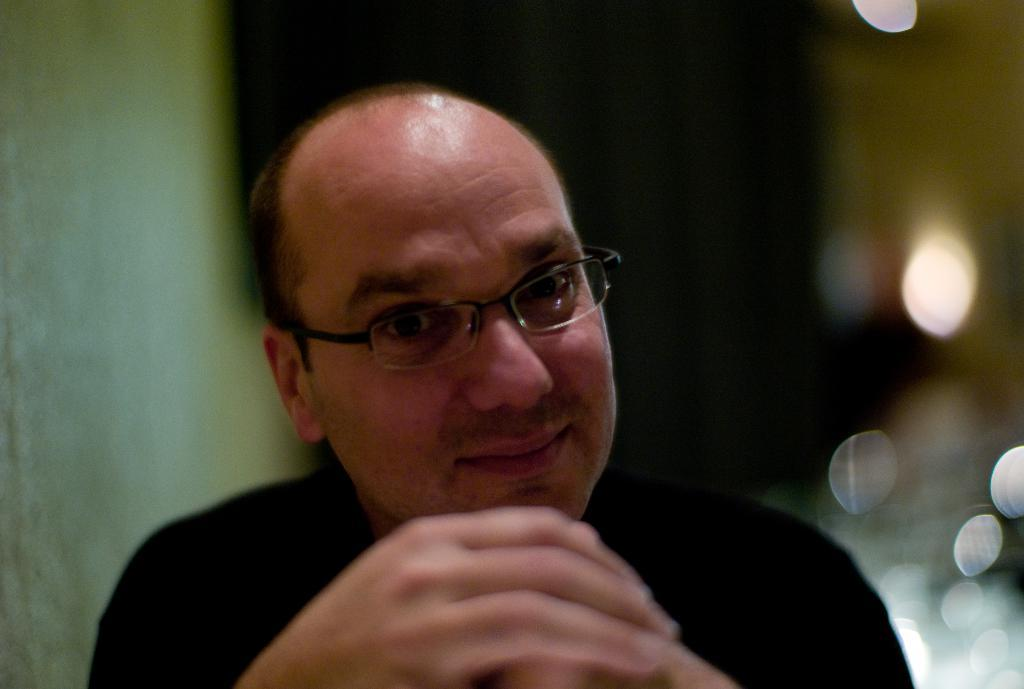Who is the main subject in the image? There is a man in the image. What is the man wearing on his face? The man is wearing glasses. What color is the dress the man is wearing? The man is wearing a black color dress. Can you describe the background of the image? The background of the image is blurry. What type of curve can be seen in the man's hair in the image? There is no curve visible in the man's hair in the image. What form does the man's hat take in the image? The man is not wearing a hat in the image. 